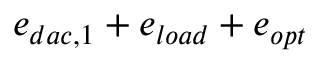<formula> <loc_0><loc_0><loc_500><loc_500>e _ { d a c , 1 } + e _ { l o a d } + e _ { o p t }</formula> 